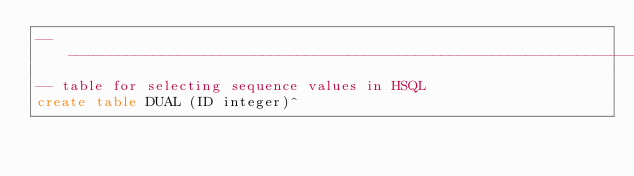Convert code to text. <code><loc_0><loc_0><loc_500><loc_500><_SQL_>------------------------------------------------------------------------------------------------------------
-- table for selecting sequence values in HSQL
create table DUAL (ID integer)^</code> 